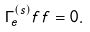<formula> <loc_0><loc_0><loc_500><loc_500>\Gamma ^ { ( s ) } _ { e } f f = 0 .</formula> 